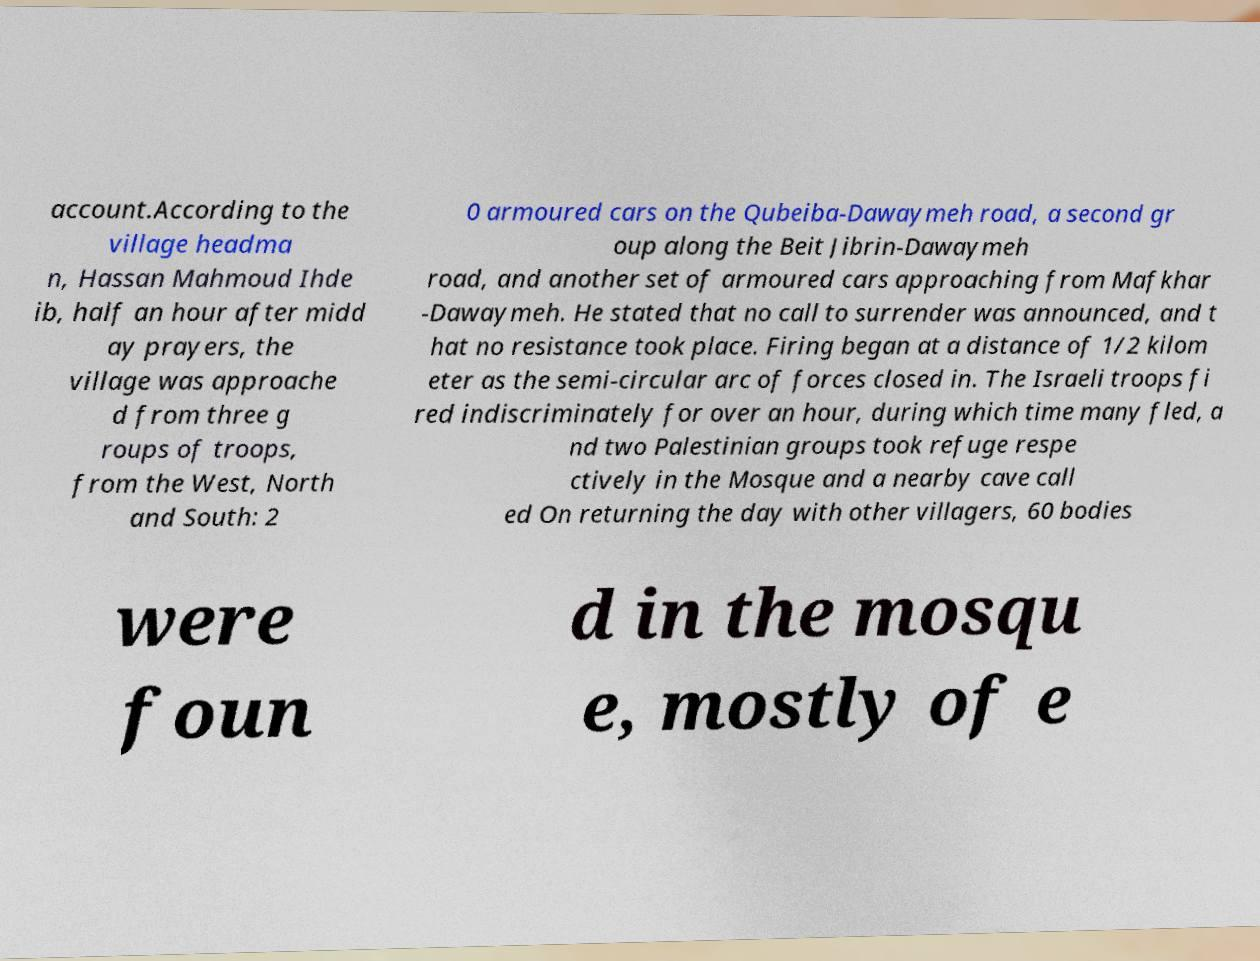What messages or text are displayed in this image? I need them in a readable, typed format. account.According to the village headma n, Hassan Mahmoud Ihde ib, half an hour after midd ay prayers, the village was approache d from three g roups of troops, from the West, North and South: 2 0 armoured cars on the Qubeiba-Dawaymeh road, a second gr oup along the Beit Jibrin-Dawaymeh road, and another set of armoured cars approaching from Mafkhar -Dawaymeh. He stated that no call to surrender was announced, and t hat no resistance took place. Firing began at a distance of 1/2 kilom eter as the semi-circular arc of forces closed in. The Israeli troops fi red indiscriminately for over an hour, during which time many fled, a nd two Palestinian groups took refuge respe ctively in the Mosque and a nearby cave call ed On returning the day with other villagers, 60 bodies were foun d in the mosqu e, mostly of e 